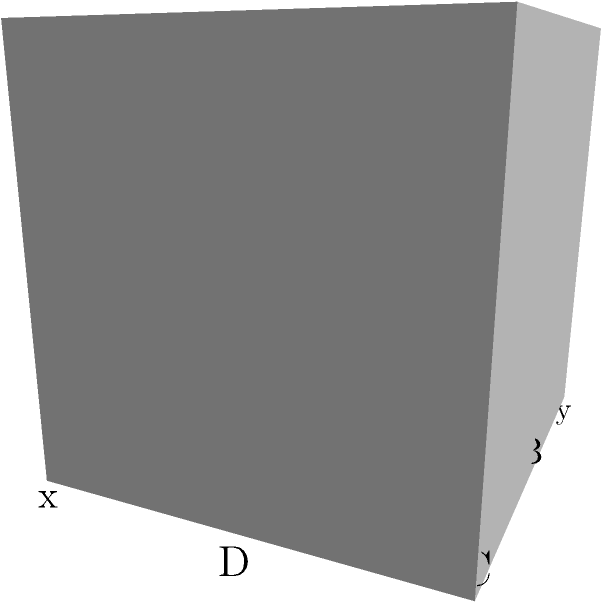In reconstructing a damaged 3D model of an ancient artifact, you've identified a missing rectangular section ABCD on the surface. Given that the coordinates of point A are (1,1,0) and the artifact's dimensions are 2x2x2 units, how would you use trigonometric interpolation to estimate the z-coordinate of point B (1,2,z) if the surrounding intact surface follows a sinusoidal pattern described by the function $z = \sin(\pi x) \sin(\pi y)$? To estimate the z-coordinate of point B using trigonometric interpolation, we'll follow these steps:

1) We're given that the surface follows the function $z = \sin(\pi x) \sin(\pi y)$.

2) The coordinates of point B are (1,2,z), where z is unknown.

3) To find z, we need to substitute x=1 and y=2 into the given function:

   $z = \sin(\pi \cdot 1) \sin(\pi \cdot 2)$

4) Simplify:
   $z = \sin(\pi) \sin(2\pi)$

5) Calculate:
   $\sin(\pi) = 0$
   $\sin(2\pi) = 0$

6) Therefore:
   $z = 0 \cdot 0 = 0$

Thus, the z-coordinate of point B is 0.

This method uses the trigonometric function to interpolate the missing data point based on the known surface pattern, allowing for an accurate reconstruction of the damaged part of the 3D model.
Answer: 0 